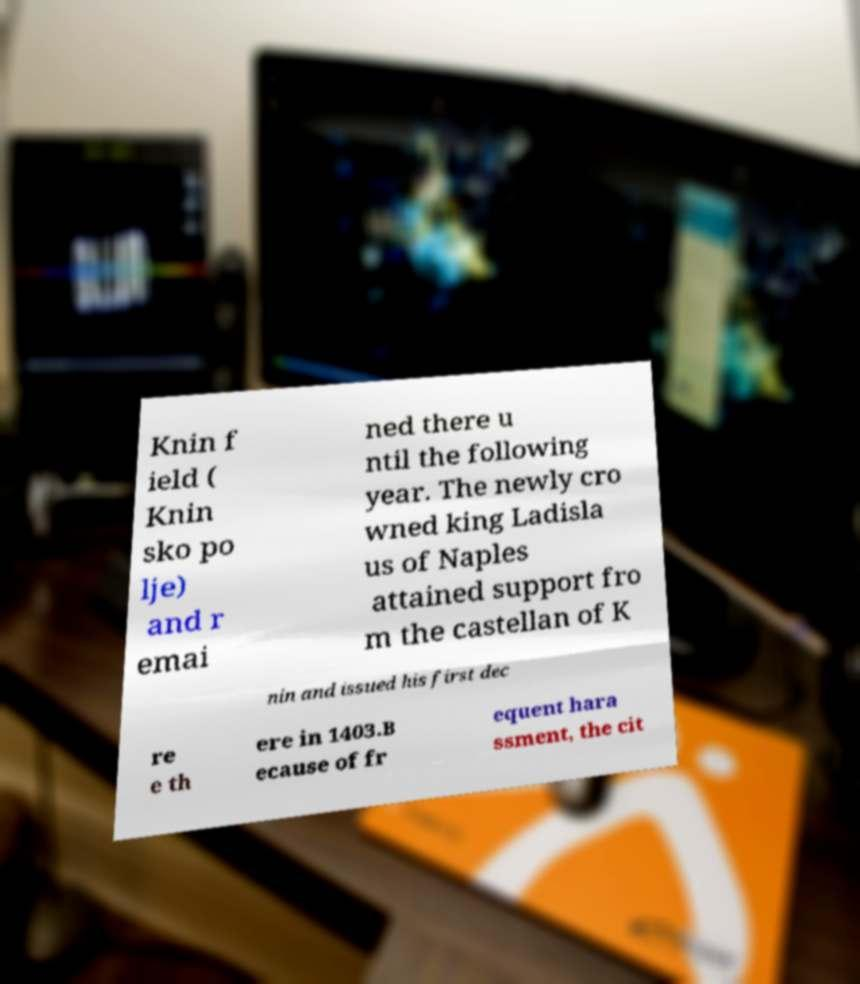What messages or text are displayed in this image? I need them in a readable, typed format. Knin f ield ( Knin sko po lje) and r emai ned there u ntil the following year. The newly cro wned king Ladisla us of Naples attained support fro m the castellan of K nin and issued his first dec re e th ere in 1403.B ecause of fr equent hara ssment, the cit 